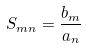Convert formula to latex. <formula><loc_0><loc_0><loc_500><loc_500>S _ { m n } = \frac { b _ { m } } { a _ { n } }</formula> 